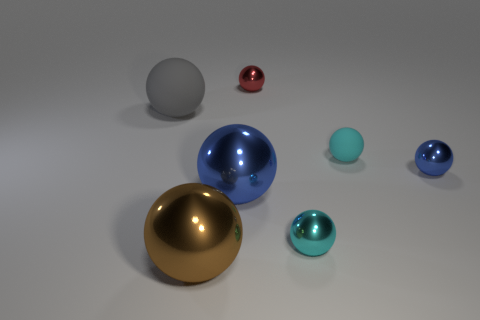Subtract all brown balls. How many balls are left? 6 Subtract all gray balls. How many balls are left? 6 Subtract all brown spheres. Subtract all red blocks. How many spheres are left? 6 Add 2 tiny red objects. How many objects exist? 9 Add 1 matte things. How many matte things exist? 3 Subtract 2 blue balls. How many objects are left? 5 Subtract all tiny cyan shiny things. Subtract all metallic objects. How many objects are left? 1 Add 1 gray matte things. How many gray matte things are left? 2 